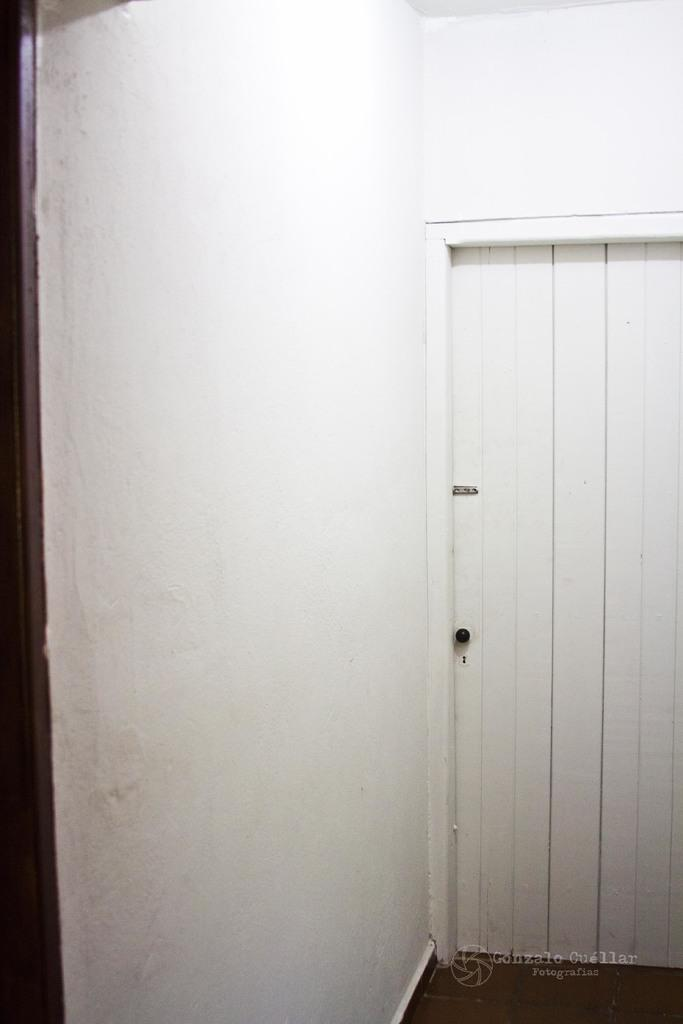What color is the wall in the image? The wall in the image is white. What feature can be found on the wall? There is a door in the image. Where is the donkey positioned in the image? A: There is no donkey present in the image. What type of building is depicted in the image? The provided facts do not mention any specific building or hospital; the image only features a white wall and a door. 